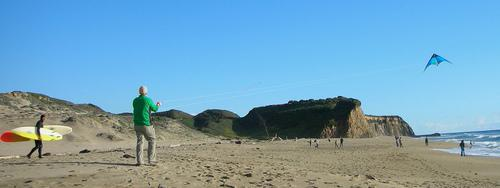Question: where was the photo taken?
Choices:
A. Under water.
B. Inside a box.
C. On the railroad.
D. At the beach.
Answer with the letter. Answer: D 